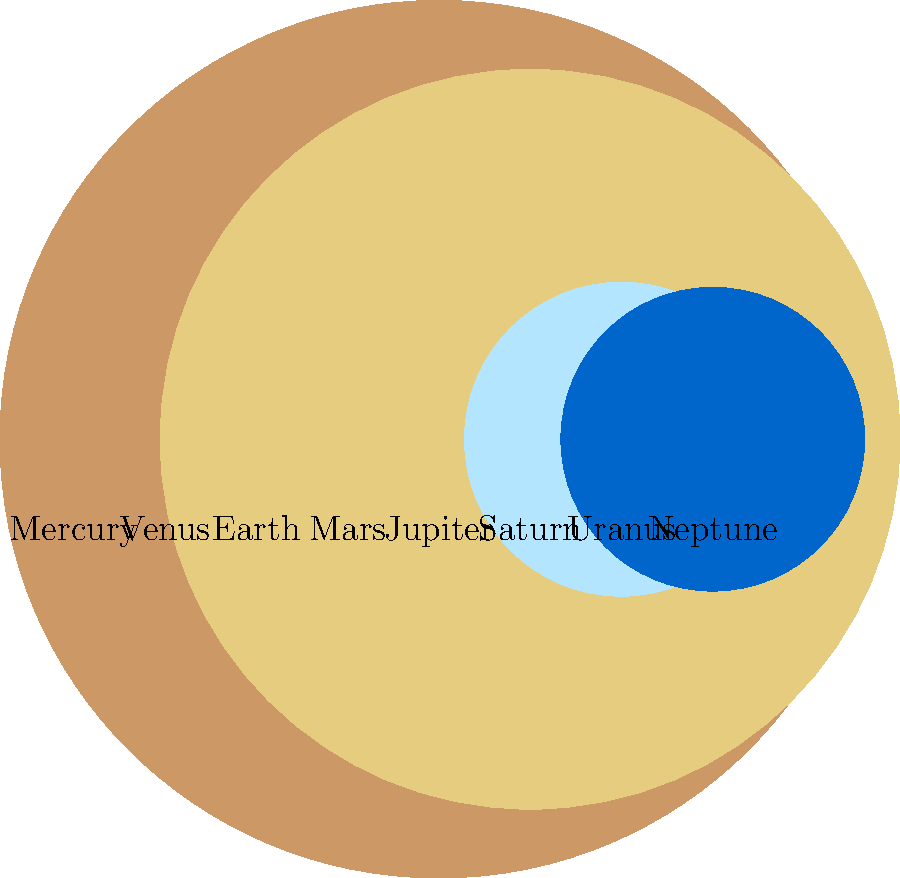As you flip through your collection of space-themed album covers, you come across a diagram showing the relative sizes of planets in our solar system. Which planet is represented by the largest circle, reminding you of the expansive sound of cosmic synthesizers from the 70s? To determine which planet is represented by the largest circle, we need to compare the sizes of all the circles in the diagram. Let's go through this step-by-step:

1. The diagram shows 8 circles representing the 8 planets in our solar system.
2. Each circle's size is proportional to the planet's actual size relative to Earth.
3. Starting from the left, we can identify:
   - Mercury (smallest)
   - Venus (slightly smaller than Earth)
   - Earth (our reference)
   - Mars (smaller than Earth)
   - Jupiter (largest circle)
   - Saturn (second largest)
   - Uranus and Neptune (similar size, smaller than Jupiter and Saturn)

4. By visual comparison, it's clear that Jupiter's circle is the largest among all planets.

5. This aligns with astronomical facts: Jupiter is indeed the largest planet in our solar system, with a diameter about 11 times that of Earth.

The largest circle in the diagram, therefore, represents Jupiter, which could indeed remind a music enthusiast of the grand, expansive sounds of 70s cosmic synthesizers due to its imposing size.
Answer: Jupiter 